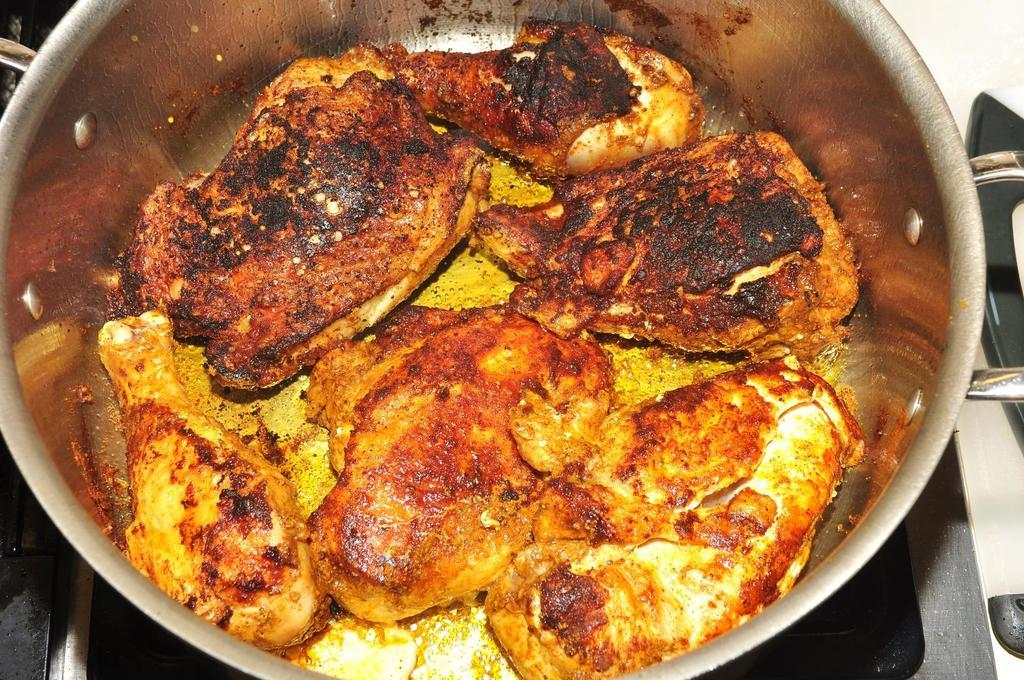What is present in the image? There is a container in the image. What is inside the container? There is a food item in the container. How many rings are being worn by the rabbits in the image? There are no rabbits or rings present in the image. 